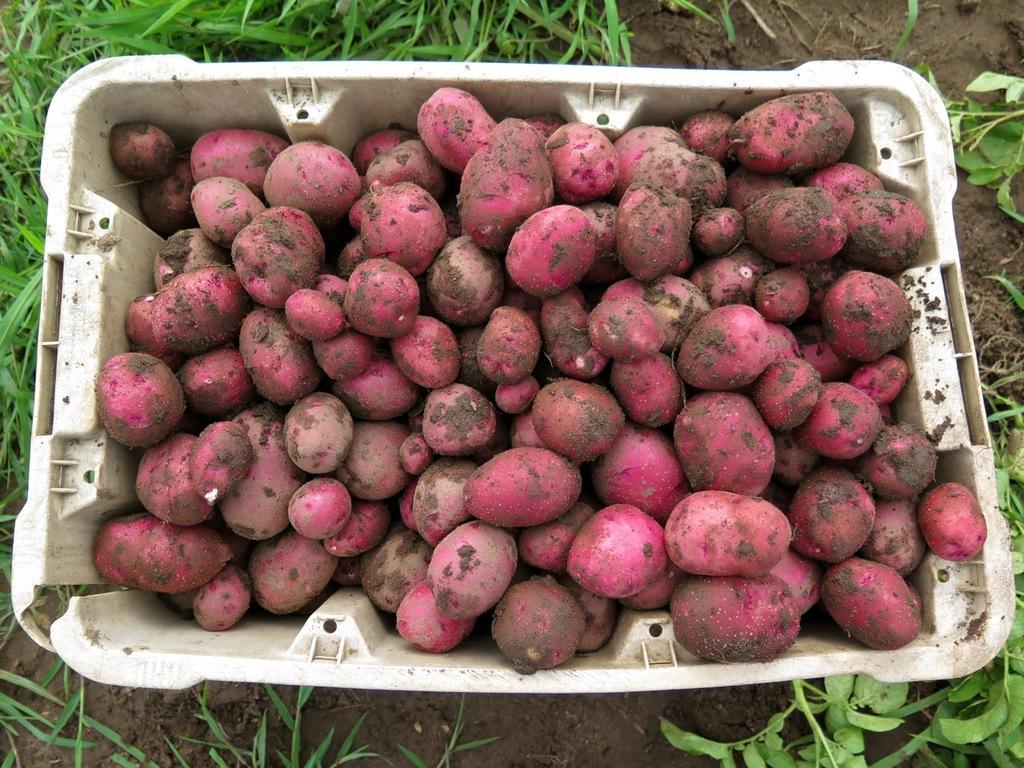Describe this image in one or two sentences. In this image we can see the grass and tub. In that tub there are some vegetables. 